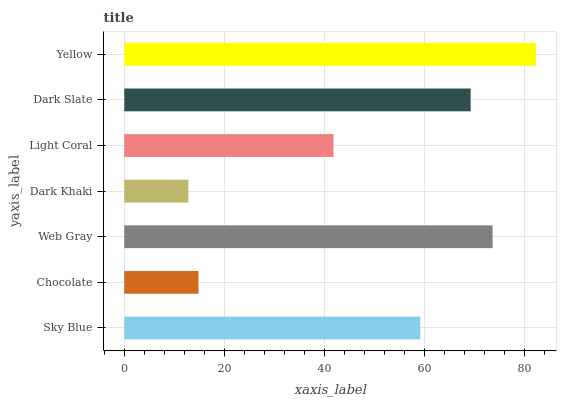Is Dark Khaki the minimum?
Answer yes or no. Yes. Is Yellow the maximum?
Answer yes or no. Yes. Is Chocolate the minimum?
Answer yes or no. No. Is Chocolate the maximum?
Answer yes or no. No. Is Sky Blue greater than Chocolate?
Answer yes or no. Yes. Is Chocolate less than Sky Blue?
Answer yes or no. Yes. Is Chocolate greater than Sky Blue?
Answer yes or no. No. Is Sky Blue less than Chocolate?
Answer yes or no. No. Is Sky Blue the high median?
Answer yes or no. Yes. Is Sky Blue the low median?
Answer yes or no. Yes. Is Dark Khaki the high median?
Answer yes or no. No. Is Dark Khaki the low median?
Answer yes or no. No. 